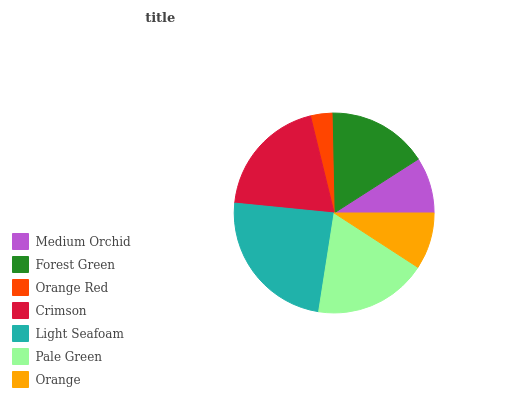Is Orange Red the minimum?
Answer yes or no. Yes. Is Light Seafoam the maximum?
Answer yes or no. Yes. Is Forest Green the minimum?
Answer yes or no. No. Is Forest Green the maximum?
Answer yes or no. No. Is Forest Green greater than Medium Orchid?
Answer yes or no. Yes. Is Medium Orchid less than Forest Green?
Answer yes or no. Yes. Is Medium Orchid greater than Forest Green?
Answer yes or no. No. Is Forest Green less than Medium Orchid?
Answer yes or no. No. Is Forest Green the high median?
Answer yes or no. Yes. Is Forest Green the low median?
Answer yes or no. Yes. Is Pale Green the high median?
Answer yes or no. No. Is Light Seafoam the low median?
Answer yes or no. No. 